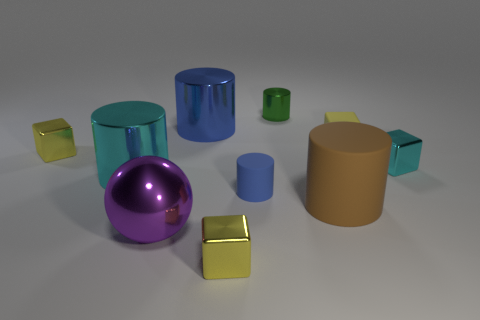What is the color of the large ball that is the same material as the tiny cyan block? The large ball sharing the same material characteristics as the tiny cyan block is purple, exhibiting a shiny, reflective surface similar to the small block. 